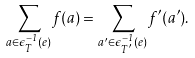<formula> <loc_0><loc_0><loc_500><loc_500>\sum _ { a \in \epsilon _ { T } ^ { - 1 } ( e ) } f ( a ) = \sum _ { a ^ { \prime } \in \epsilon _ { T ^ { \prime } } ^ { - 1 } ( e ) } f ^ { \prime } ( a ^ { \prime } ) .</formula> 